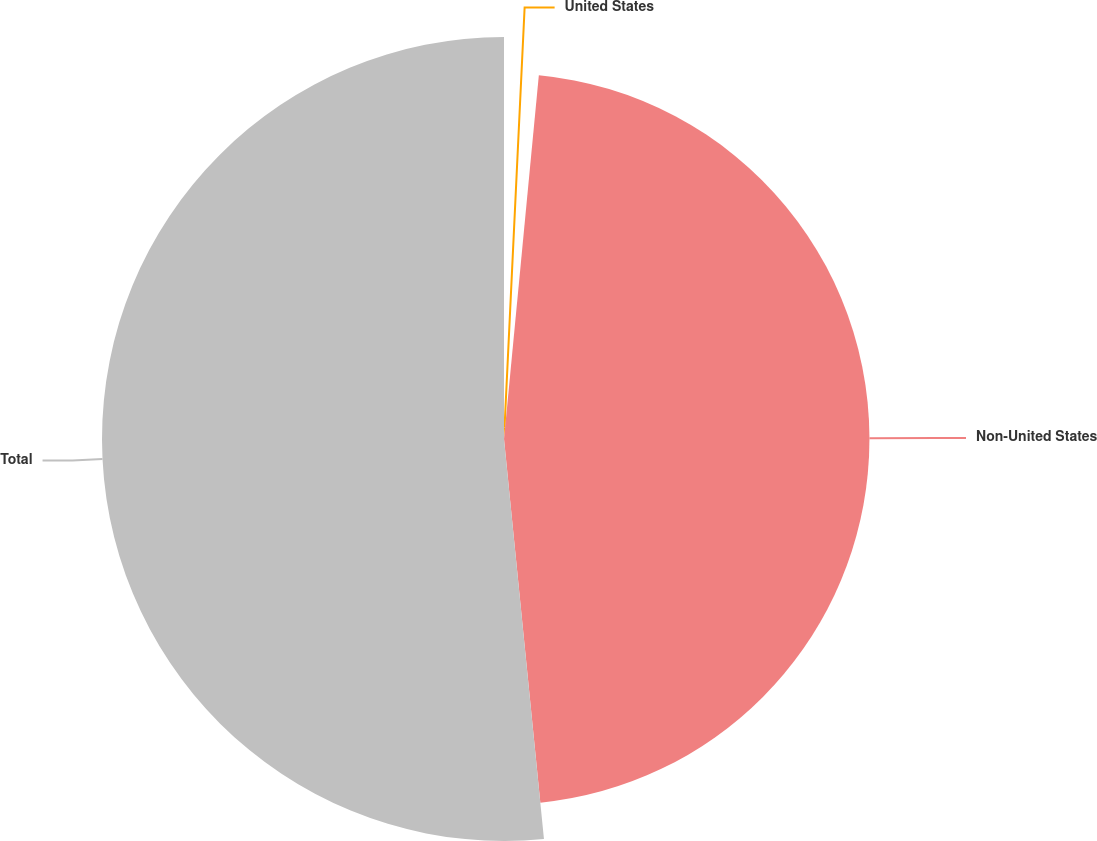<chart> <loc_0><loc_0><loc_500><loc_500><pie_chart><fcel>United States<fcel>Non-United States<fcel>Total<nl><fcel>1.52%<fcel>46.9%<fcel>51.59%<nl></chart> 